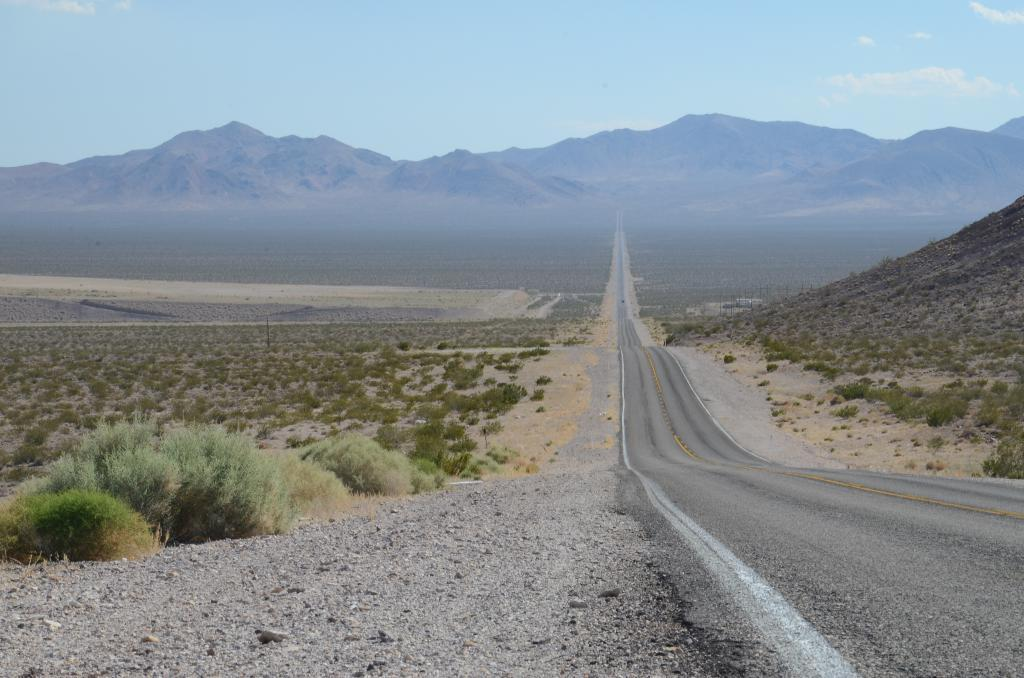What type of terrain is visible in the image? There is a road and sand visible in the image. What natural features can be seen in the image? There are mountains and plants visible in the image. What is visible in the background of the image? The sky is visible in the background of the image. What type of trouble can be seen in the image? There is no indication of trouble in the image; it features a road, mountains, plants, sand, and the sky. What type of mass is visible in the image? There is no mass present in the image. What type of plough can be seen in the image? There is no plough present in the image. 